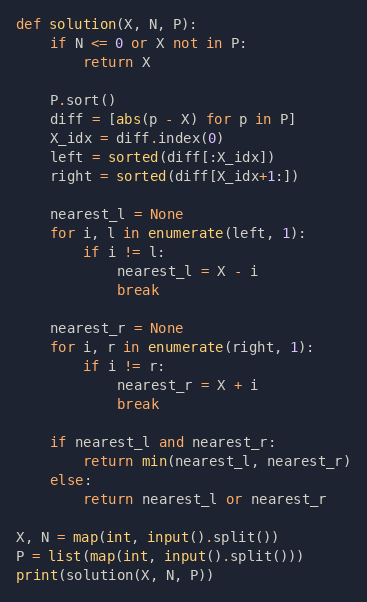<code> <loc_0><loc_0><loc_500><loc_500><_Python_>def solution(X, N, P):
    if N <= 0 or X not in P:
        return X

    P.sort()
    diff = [abs(p - X) for p in P]
    X_idx = diff.index(0)
    left = sorted(diff[:X_idx])
    right = sorted(diff[X_idx+1:])

    nearest_l = None
    for i, l in enumerate(left, 1):
        if i != l:
            nearest_l = X - i
            break
    
    nearest_r = None
    for i, r in enumerate(right, 1):
        if i != r:
            nearest_r = X + i
            break
    
    if nearest_l and nearest_r:
        return min(nearest_l, nearest_r)
    else:
        return nearest_l or nearest_r

X, N = map(int, input().split())
P = list(map(int, input().split()))
print(solution(X, N, P))
</code> 